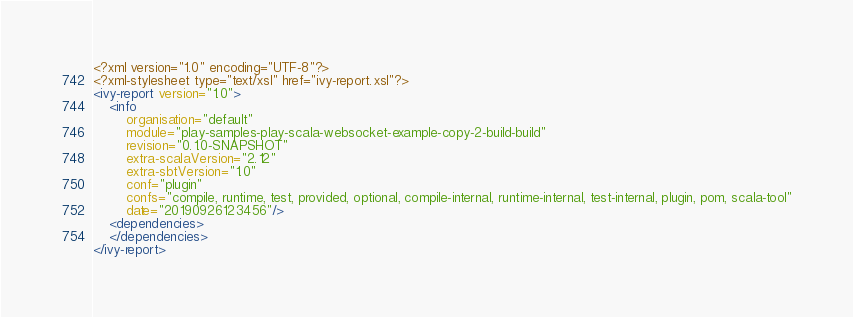<code> <loc_0><loc_0><loc_500><loc_500><_XML_><?xml version="1.0" encoding="UTF-8"?>
<?xml-stylesheet type="text/xsl" href="ivy-report.xsl"?>
<ivy-report version="1.0">
	<info
		organisation="default"
		module="play-samples-play-scala-websocket-example-copy-2-build-build"
		revision="0.1.0-SNAPSHOT"
		extra-scalaVersion="2.12"
		extra-sbtVersion="1.0"
		conf="plugin"
		confs="compile, runtime, test, provided, optional, compile-internal, runtime-internal, test-internal, plugin, pom, scala-tool"
		date="20190926123456"/>
	<dependencies>
	</dependencies>
</ivy-report>
</code> 